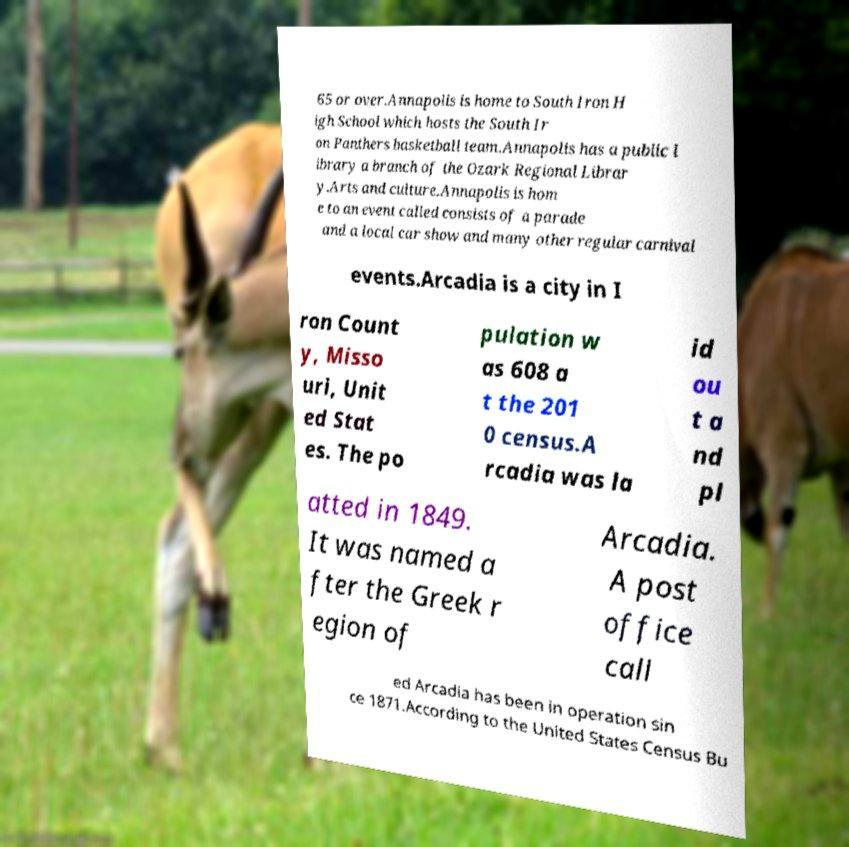Can you accurately transcribe the text from the provided image for me? 65 or over.Annapolis is home to South Iron H igh School which hosts the South Ir on Panthers basketball team.Annapolis has a public l ibrary a branch of the Ozark Regional Librar y.Arts and culture.Annapolis is hom e to an event called consists of a parade and a local car show and many other regular carnival events.Arcadia is a city in I ron Count y, Misso uri, Unit ed Stat es. The po pulation w as 608 a t the 201 0 census.A rcadia was la id ou t a nd pl atted in 1849. It was named a fter the Greek r egion of Arcadia. A post office call ed Arcadia has been in operation sin ce 1871.According to the United States Census Bu 